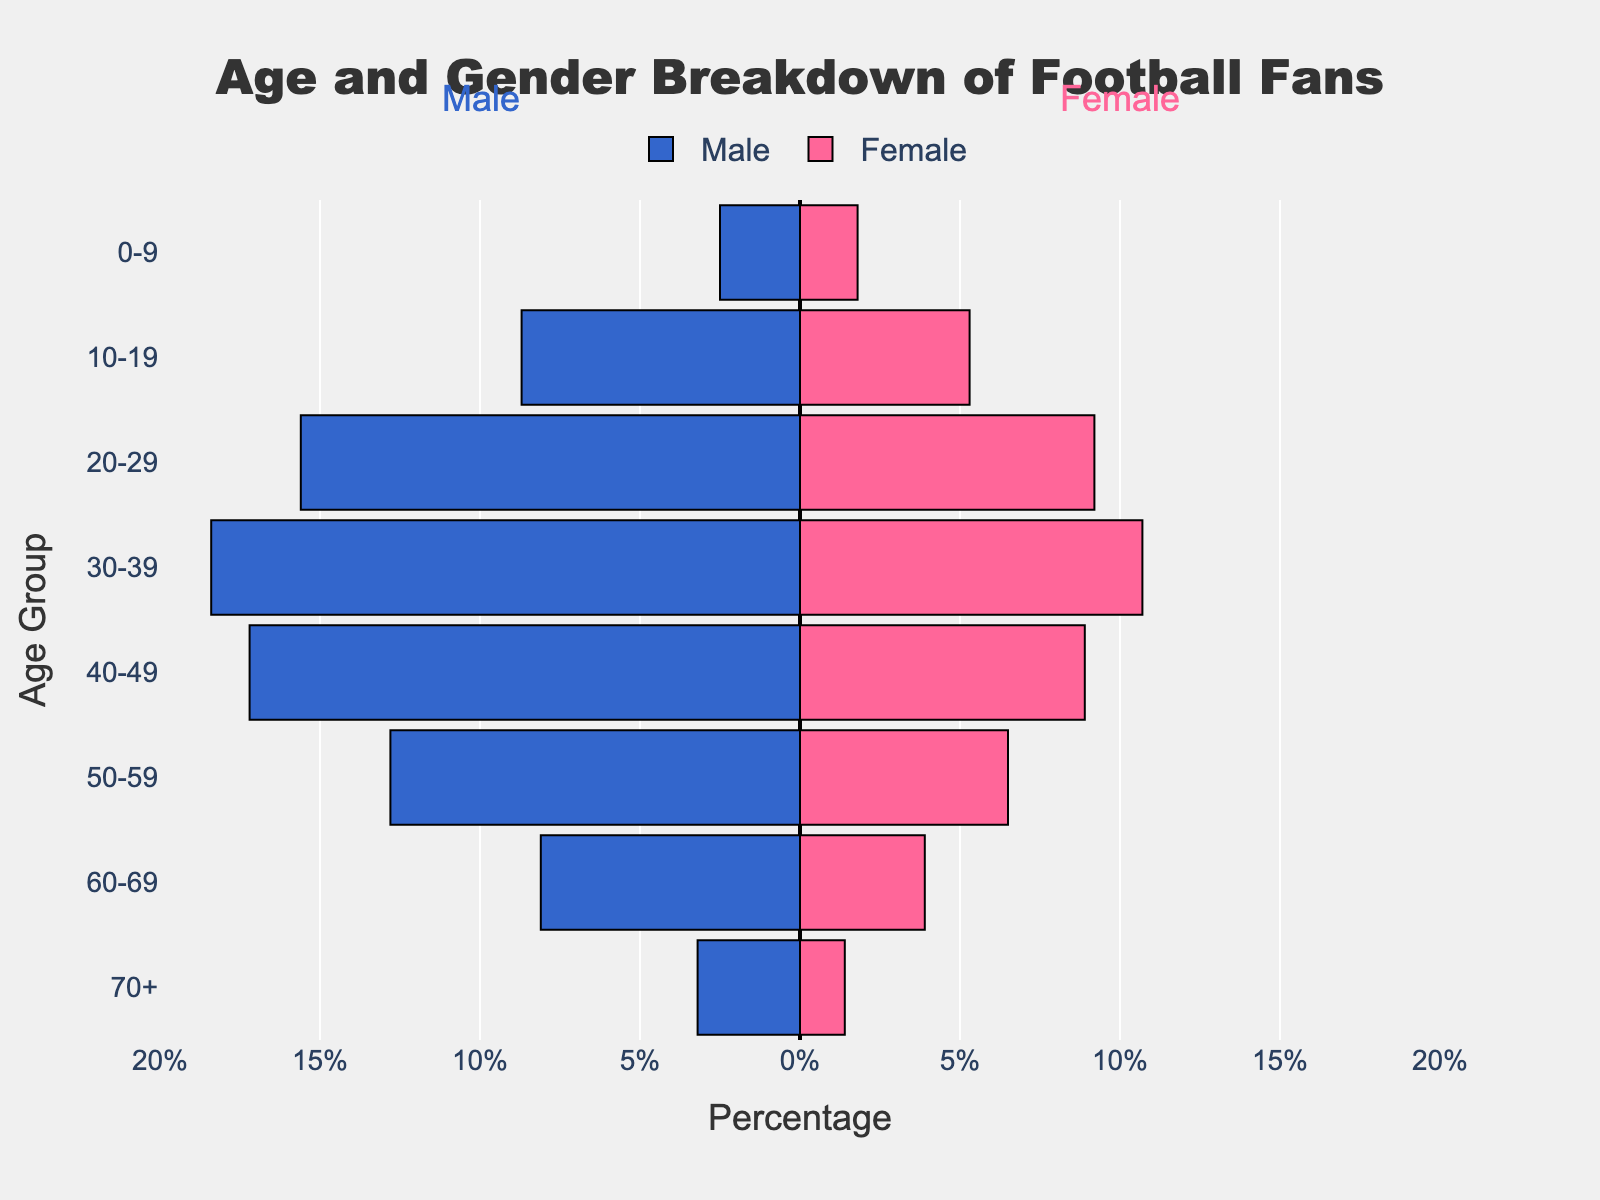What's the title of the figure? The title of the figure is usually located at the top of the chart. Here, it should be visible in the centralized position and in a larger font.
Answer: Age and Gender Breakdown of Football Fans Which gender has a higher percentage in the 30-39 age group? Look at the 30-39 age group on the vertical axis and compare the lengths of the bars extending to the left and right. The bar extending to the left represents males, and the one extending to the right represents females.
Answer: Male What is the percentage of female fans in the 20-29 age group? Locate the 20-29 age group on the vertical axis and look at the length of the bar extending to the right (which represents females). The hover template or tick markers will show the percentage.
Answer: 9.2% Which age group has the smallest percentage of male fans? Look at all the male bars (extending to the left) and find the shortest one. Trace it back to the age group on the vertical axis.
Answer: 70+ What is the total percentage of football fans (both genders) in the 10-19 age group? Find the percentages of both males (8.7%) and females (5.3%) in the 10-19 age group, then add them together. This requires two operations: addition of male and female percentages.
Answer: 14% In which age group is the difference between male and female percentages the largest? For each age group, subtract the female percentage from the male percentage and identify the group with the highest difference. Calculation: (15.6 - 9.2) for 20-29, (18.4 - 10.7) for 30-39, (17.2 - 8.9) for 40-49, etc. The largest difference can then be determined.
Answer: 30-39 How does the percentage of female fans aged 40-49 compare to the percentage of male fans aged 60-69? Compare the bar lengths for female fans aged 40-49 and male fans aged 60-69 to see which is longer.
Answer: Female 40-49 (8.9%) is greater than Male 60-69 (8.1%) What is the average percentage of female fans across all age groups? Add the percentages of female fans from all age groups and then divide by the number of age groups. (1.8 + 5.3 + 9.2 + 10.7 + 8.9 + 6.5 + 3.9 + 1.4) / 8
Answer: 5.96% Is there an age group where the percentage of female fans is higher than the percentage of male fans? Check each age group and compare the female bar length with the male bar length to see if any female bar extends further than the male bar.
Answer: No What is the total percentage of male fans in the 50-59 and 60-69 age groups combined? Add the percentages of male fans in the 50-59 (12.8%) and 60-69 (8.1%) age groups. This is a compositional question that involves addition.
Answer: 20.9% 